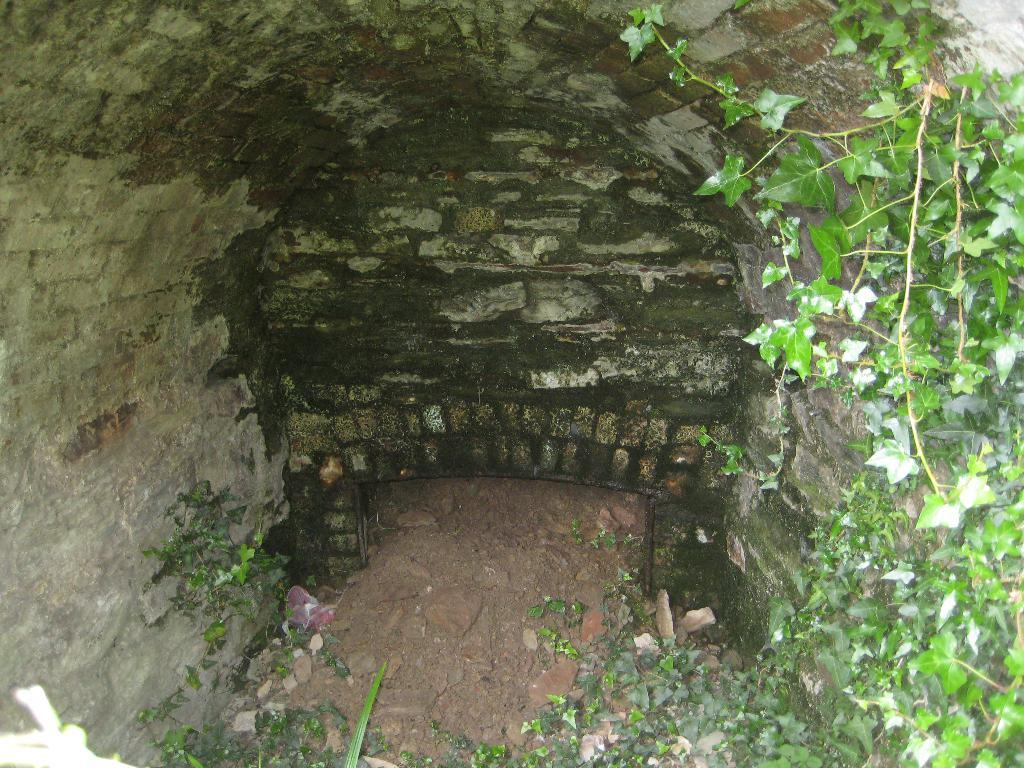What type of structure is present in the image? There is a tunnel shed in the image. What can be seen on the ground in the image? There are plants and stones on the ground in the image. Where is the river flowing in the image? There is no river present in the image. What type of ice can be seen melting on the ground in the image? There is no ice present in the image. 